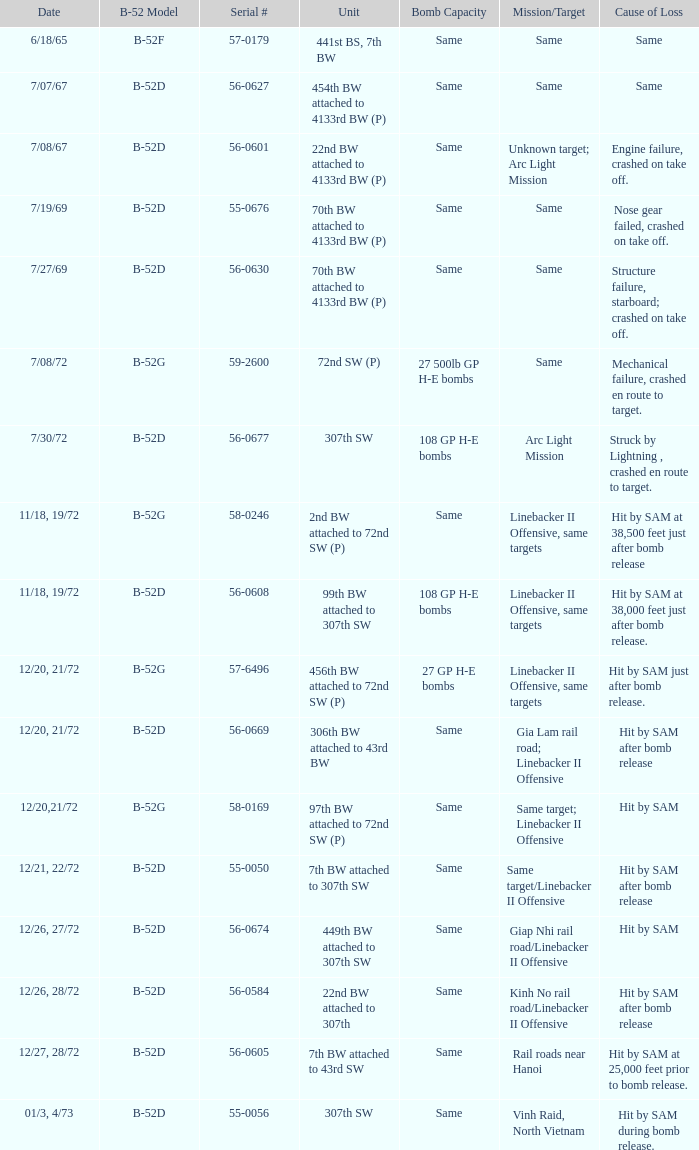What is the reason for loss when 27 gp h-e bombs have the capacity of the bomb? Hit by SAM just after bomb release. 